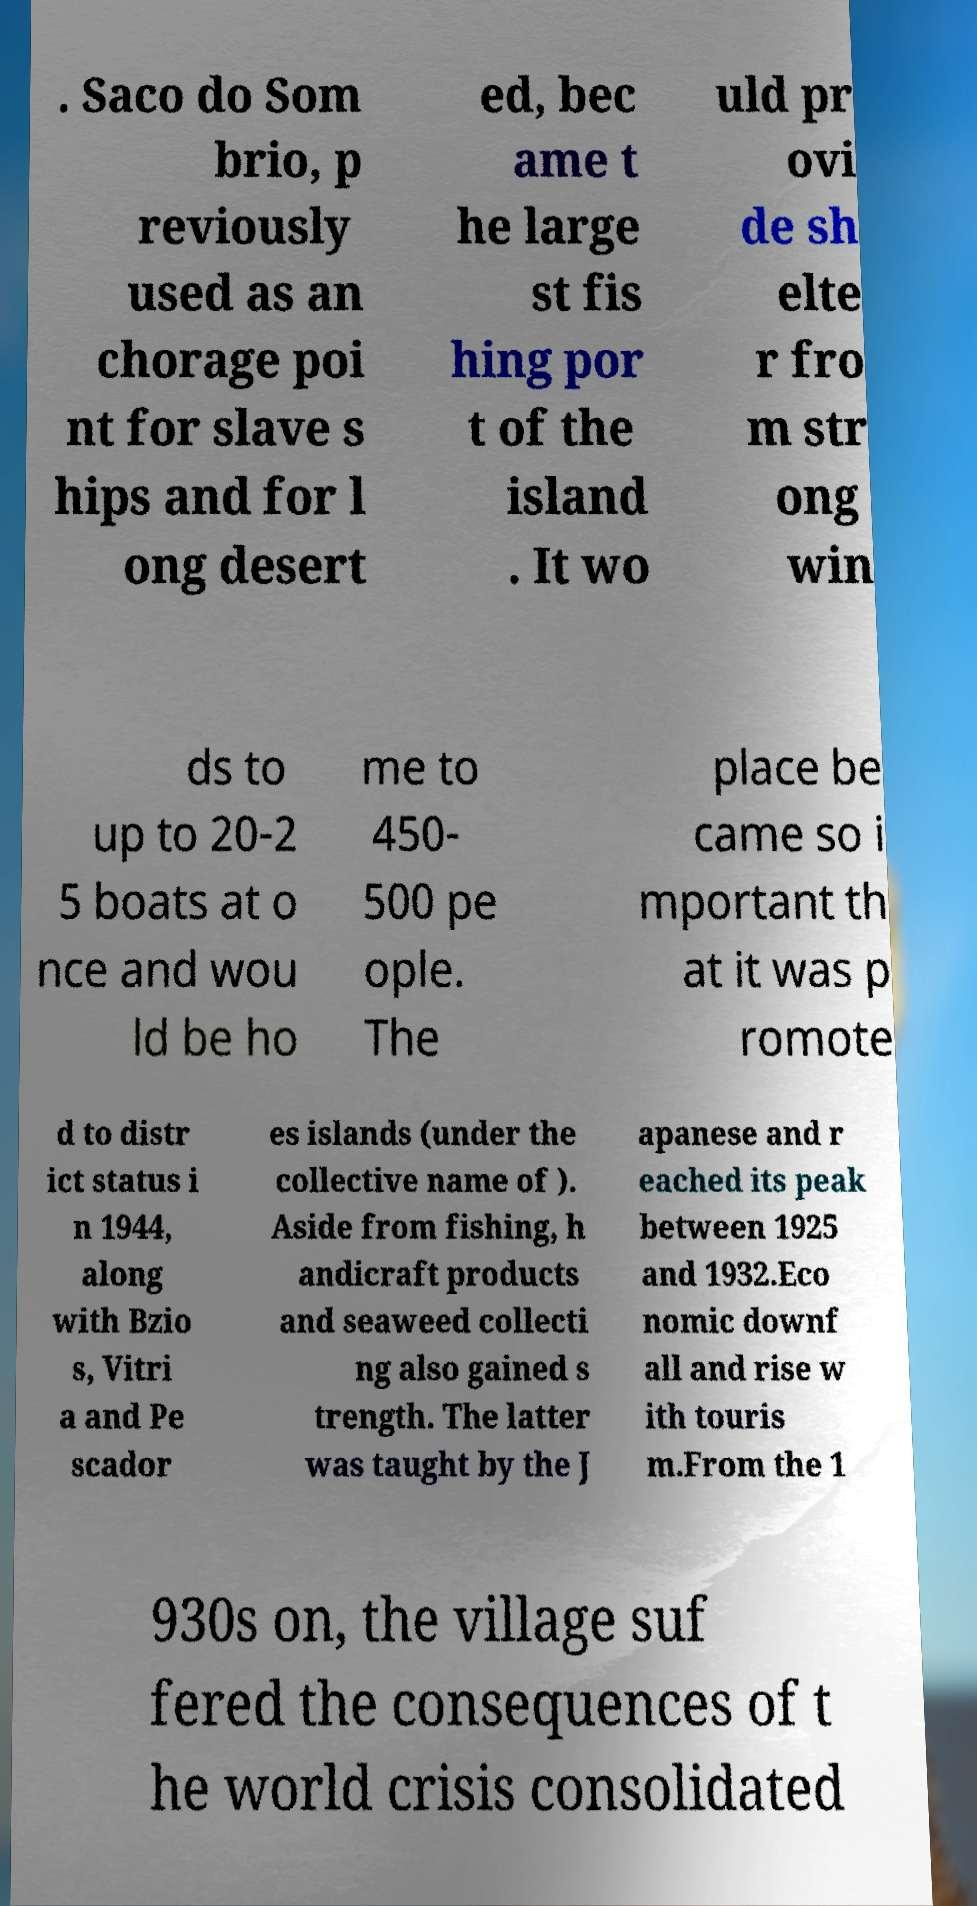Can you accurately transcribe the text from the provided image for me? . Saco do Som brio, p reviously used as an chorage poi nt for slave s hips and for l ong desert ed, bec ame t he large st fis hing por t of the island . It wo uld pr ovi de sh elte r fro m str ong win ds to up to 20-2 5 boats at o nce and wou ld be ho me to 450- 500 pe ople. The place be came so i mportant th at it was p romote d to distr ict status i n 1944, along with Bzio s, Vitri a and Pe scador es islands (under the collective name of ). Aside from fishing, h andicraft products and seaweed collecti ng also gained s trength. The latter was taught by the J apanese and r eached its peak between 1925 and 1932.Eco nomic downf all and rise w ith touris m.From the 1 930s on, the village suf fered the consequences of t he world crisis consolidated 